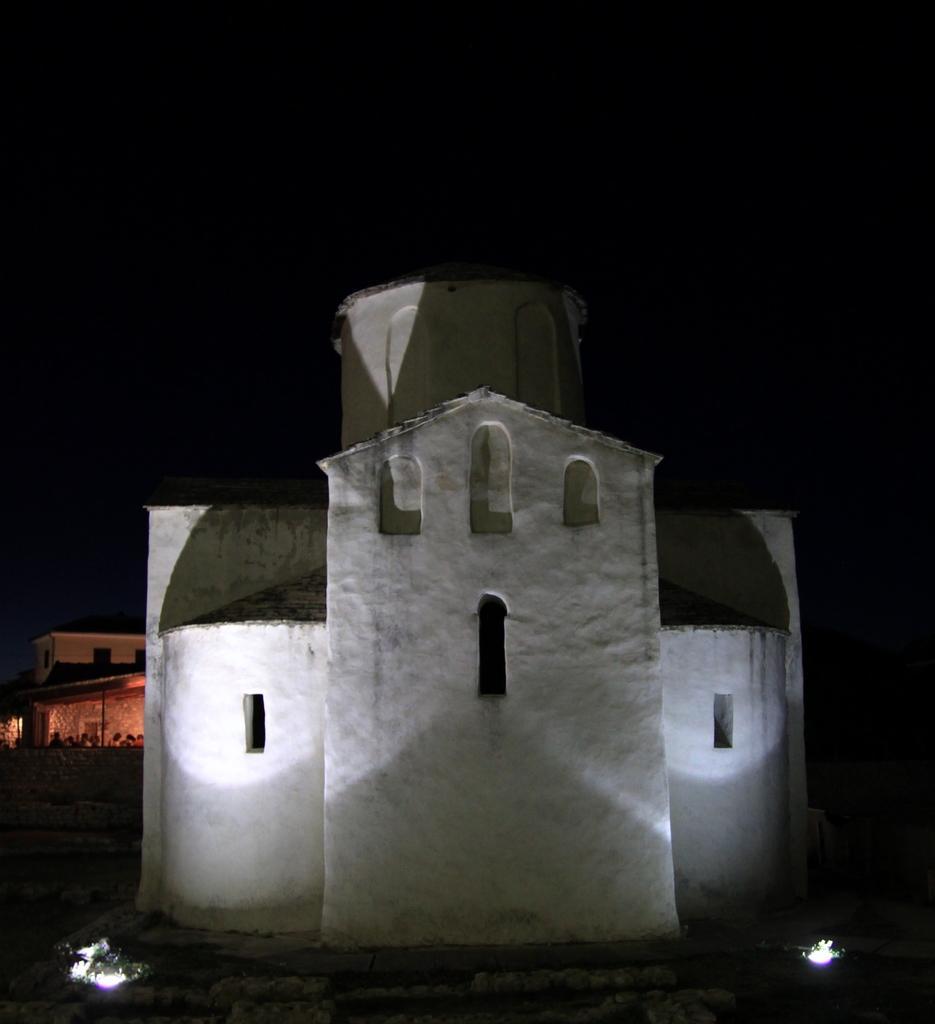Describe this image in one or two sentences. In this image there are buildings. At the bottom there are lights. 